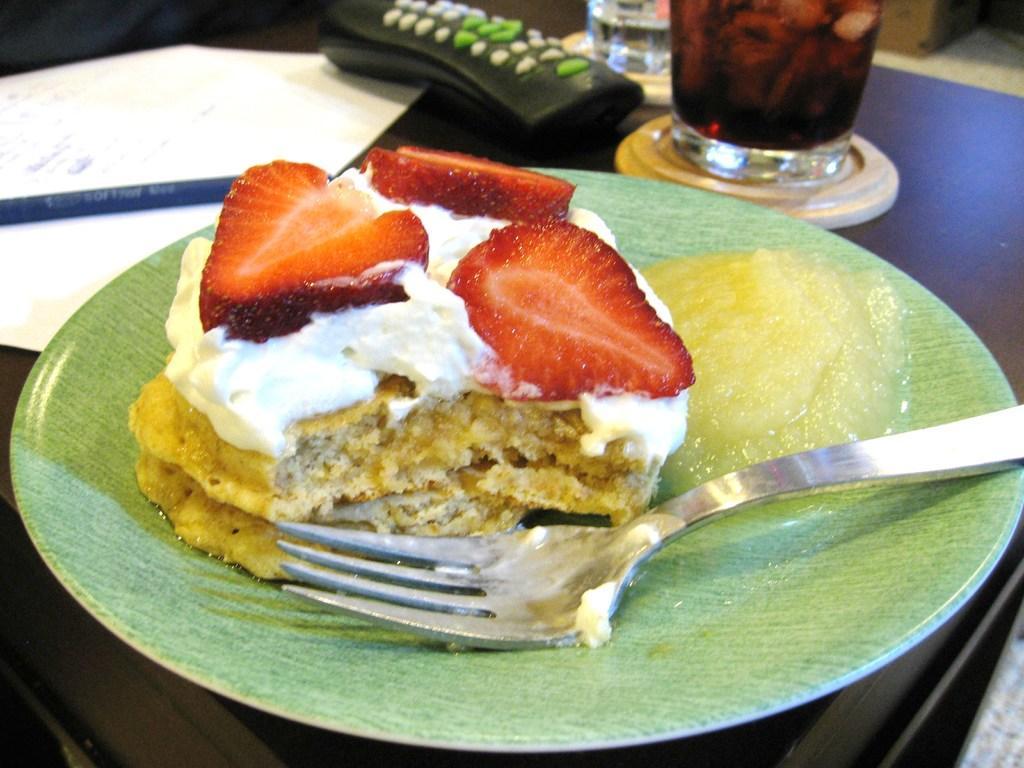Could you give a brief overview of what you see in this image? In this image there is a food item placed on a plate and a fork, in front of the plate there is a paper, pen, remote and two glasses of drinks are placed on the table. 